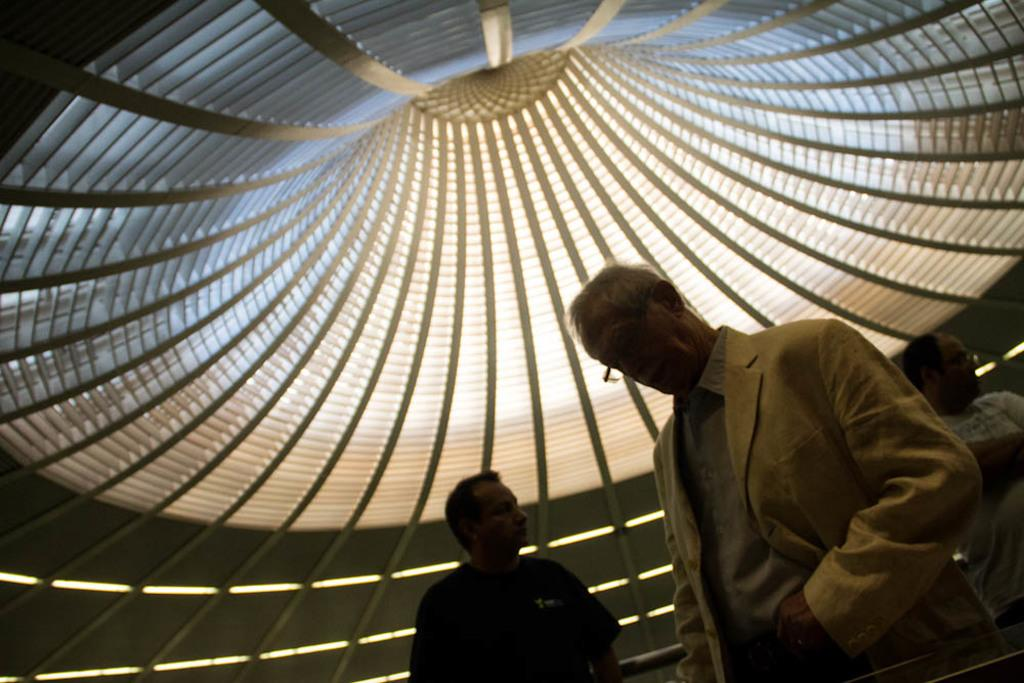What type of location is depicted in the image? The image shows an inside view of a building. How many people are in the image? There are three men in the image. What are the men doing in the image? The men are standing. Can you describe the attire of the man in front? The man in front is wearing formal dress. What caused the man in the middle to feel disgusted in the image? There is no indication in the image that any of the men are feeling disgusted, so it cannot be determined from the picture. 